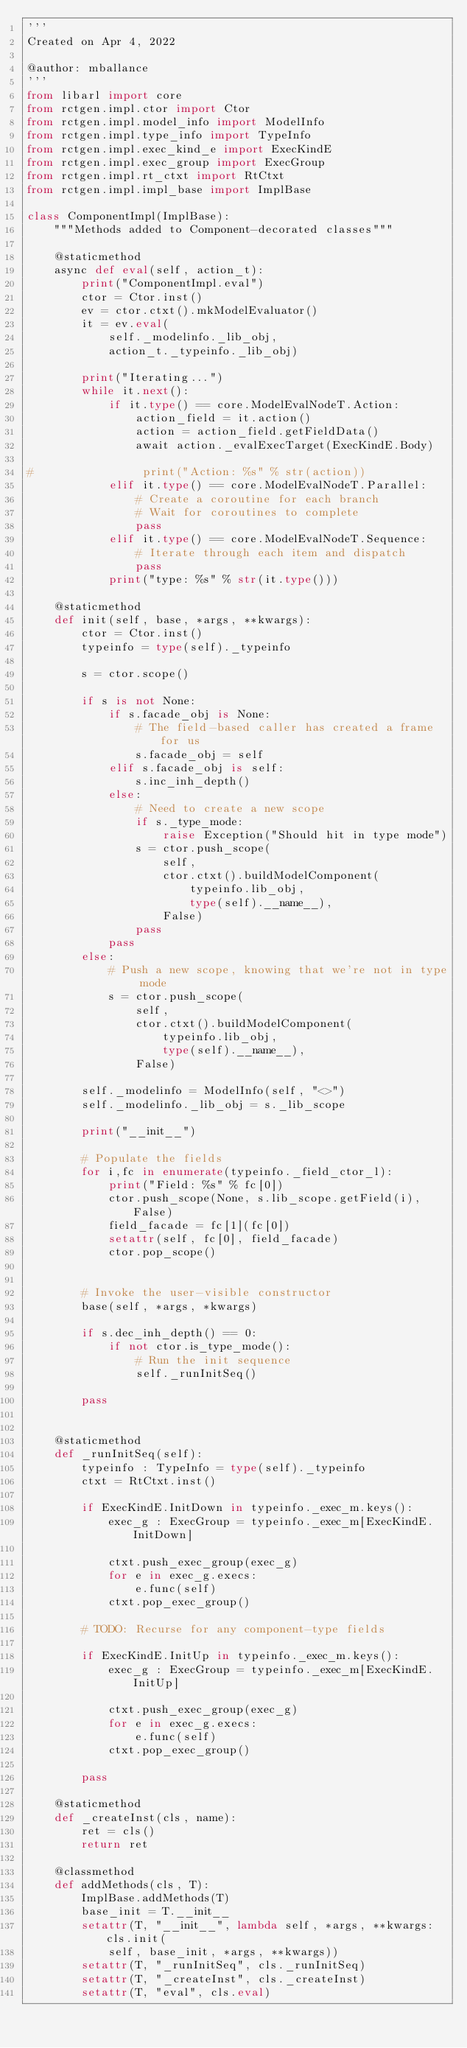<code> <loc_0><loc_0><loc_500><loc_500><_Python_>'''
Created on Apr 4, 2022

@author: mballance
'''
from libarl import core
from rctgen.impl.ctor import Ctor
from rctgen.impl.model_info import ModelInfo
from rctgen.impl.type_info import TypeInfo
from rctgen.impl.exec_kind_e import ExecKindE
from rctgen.impl.exec_group import ExecGroup
from rctgen.impl.rt_ctxt import RtCtxt
from rctgen.impl.impl_base import ImplBase

class ComponentImpl(ImplBase):
    """Methods added to Component-decorated classes"""
    
    @staticmethod
    async def eval(self, action_t):
        print("ComponentImpl.eval")
        ctor = Ctor.inst()
        ev = ctor.ctxt().mkModelEvaluator()
        it = ev.eval(
            self._modelinfo._lib_obj,
            action_t._typeinfo._lib_obj)

        print("Iterating...")        
        while it.next():
            if it.type() == core.ModelEvalNodeT.Action:
                action_field = it.action()
                action = action_field.getFieldData()
                await action._evalExecTarget(ExecKindE.Body)
            
#                print("Action: %s" % str(action))
            elif it.type() == core.ModelEvalNodeT.Parallel:
                # Create a coroutine for each branch
                # Wait for coroutines to complete
                pass
            elif it.type() == core.ModelEvalNodeT.Sequence:
                # Iterate through each item and dispatch
                pass
            print("type: %s" % str(it.type()))
        
    @staticmethod
    def init(self, base, *args, **kwargs):
        ctor = Ctor.inst()
        typeinfo = type(self)._typeinfo
        
        s = ctor.scope()
        
        if s is not None:
            if s.facade_obj is None:
                # The field-based caller has created a frame for us
                s.facade_obj = self
            elif s.facade_obj is self:
                s.inc_inh_depth()
            else:
                # Need to create a new scope
                if s._type_mode:
                    raise Exception("Should hit in type mode")
                s = ctor.push_scope(
                    self,
                    ctor.ctxt().buildModelComponent(
                        typeinfo.lib_obj,
                        type(self).__name__),
                    False)
                pass
            pass
        else:
            # Push a new scope, knowing that we're not in type mode
            s = ctor.push_scope(
                self,
                ctor.ctxt().buildModelComponent(
                    typeinfo.lib_obj,
                    type(self).__name__),
                False)
        
        self._modelinfo = ModelInfo(self, "<>")
        self._modelinfo._lib_obj = s._lib_scope
        
        print("__init__")
        
        # Populate the fields
        for i,fc in enumerate(typeinfo._field_ctor_l):
            print("Field: %s" % fc[0])
            ctor.push_scope(None, s.lib_scope.getField(i), False)
            field_facade = fc[1](fc[0])
            setattr(self, fc[0], field_facade)
            ctor.pop_scope()
            

        # Invoke the user-visible constructor        
        base(self, *args, *kwargs)
        
        if s.dec_inh_depth() == 0:
            if not ctor.is_type_mode():
                # Run the init sequence
                self._runInitSeq()
        
        pass
        

    @staticmethod        
    def _runInitSeq(self):
        typeinfo : TypeInfo = type(self)._typeinfo
        ctxt = RtCtxt.inst()
        
        if ExecKindE.InitDown in typeinfo._exec_m.keys():
            exec_g : ExecGroup = typeinfo._exec_m[ExecKindE.InitDown]

            ctxt.push_exec_group(exec_g)
            for e in exec_g.execs:
                e.func(self)
            ctxt.pop_exec_group()
                
        # TODO: Recurse for any component-type fields
        
        if ExecKindE.InitUp in typeinfo._exec_m.keys():
            exec_g : ExecGroup = typeinfo._exec_m[ExecKindE.InitUp]
            
            ctxt.push_exec_group(exec_g)
            for e in exec_g.execs:
                e.func(self)
            ctxt.pop_exec_group()
            
        pass
    
    @staticmethod
    def _createInst(cls, name):
        ret = cls()
        return ret
    
    @classmethod
    def addMethods(cls, T):
        ImplBase.addMethods(T)
        base_init = T.__init__
        setattr(T, "__init__", lambda self, *args, **kwargs: cls.init(
            self, base_init, *args, **kwargs))
        setattr(T, "_runInitSeq", cls._runInitSeq)
        setattr(T, "_createInst", cls._createInst)
        setattr(T, "eval", cls.eval)
        </code> 